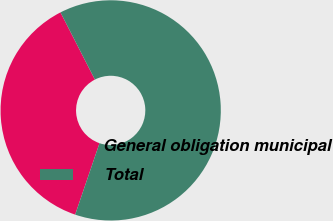Convert chart to OTSL. <chart><loc_0><loc_0><loc_500><loc_500><pie_chart><fcel>General obligation municipal<fcel>Total<nl><fcel>37.24%<fcel>62.76%<nl></chart> 